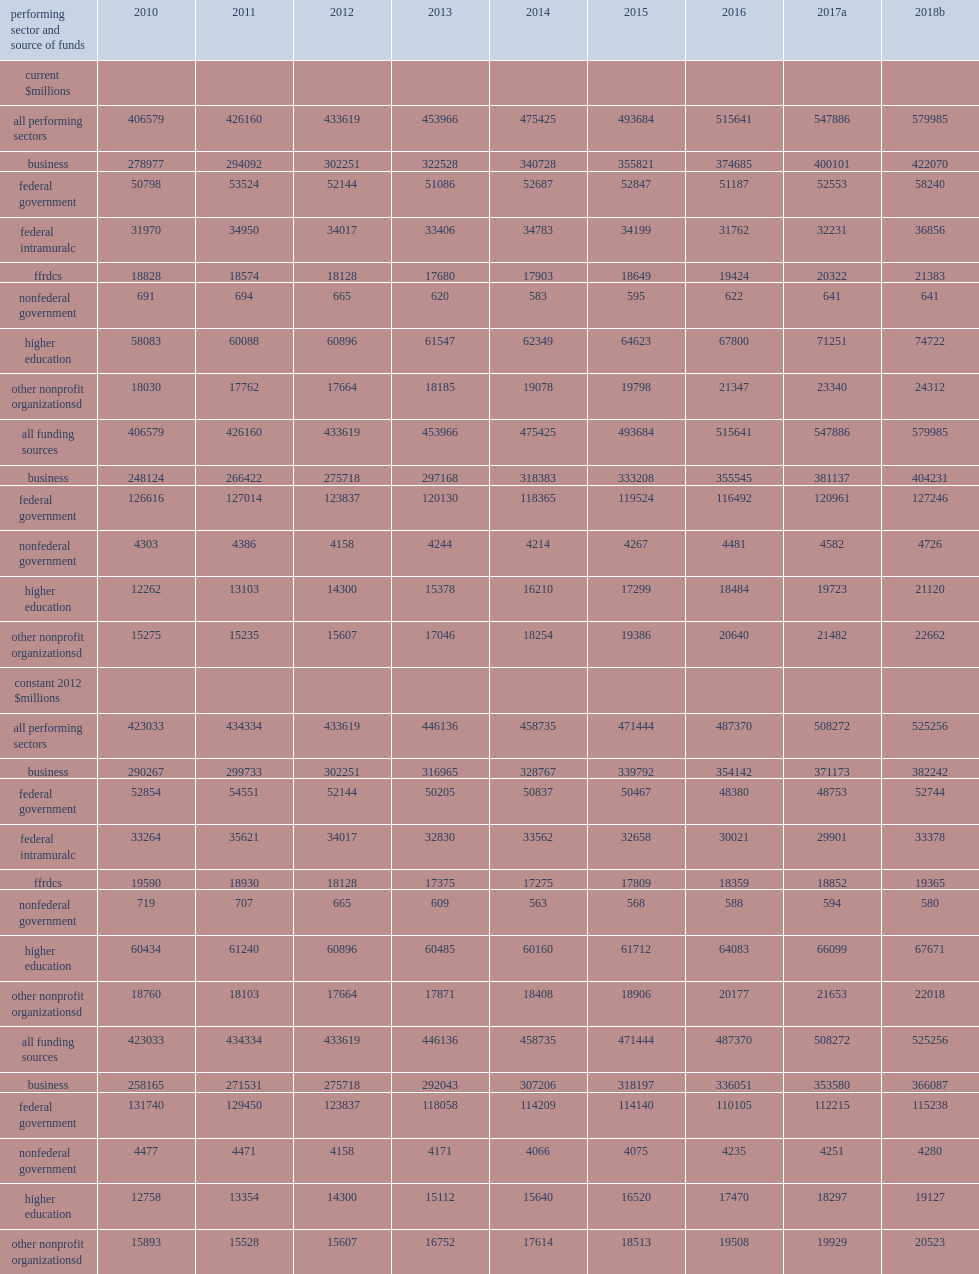How many million dollars did research and experimental development (r&d) perform in the united states in 2017? 547886.0. How many dollars was the estimated total for 2018, based on performer-reported expectations? 579985.0. How many million dollars did u.s. r&d total of in 2015? 493684.0. How many million dollars did u.s. r&d total of in 2010? 406579.0. 